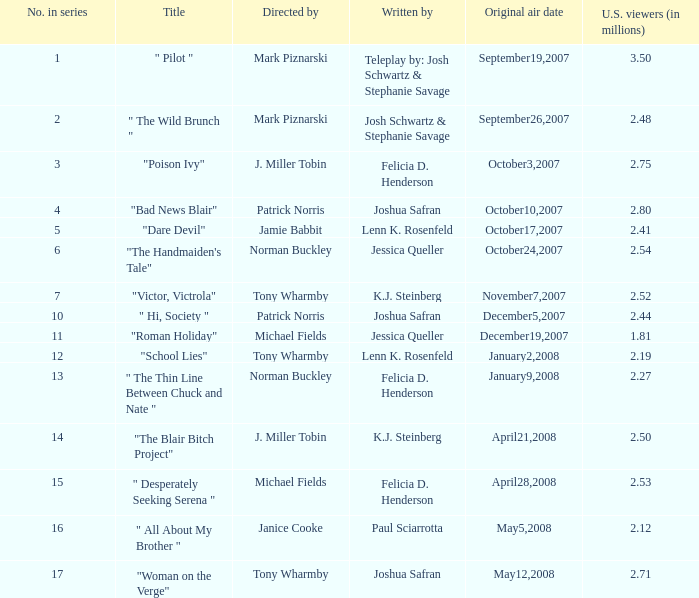What is the title when 2.50 is u.s. viewers (in millions)?  "The Blair Bitch Project". Parse the table in full. {'header': ['No. in series', 'Title', 'Directed by', 'Written by', 'Original air date', 'U.S. viewers (in millions)'], 'rows': [['1', '" Pilot "', 'Mark Piznarski', 'Teleplay by: Josh Schwartz & Stephanie Savage', 'September19,2007', '3.50'], ['2', '" The Wild Brunch "', 'Mark Piznarski', 'Josh Schwartz & Stephanie Savage', 'September26,2007', '2.48'], ['3', '"Poison Ivy"', 'J. Miller Tobin', 'Felicia D. Henderson', 'October3,2007', '2.75'], ['4', '"Bad News Blair"', 'Patrick Norris', 'Joshua Safran', 'October10,2007', '2.80'], ['5', '"Dare Devil"', 'Jamie Babbit', 'Lenn K. Rosenfeld', 'October17,2007', '2.41'], ['6', '"The Handmaiden\'s Tale"', 'Norman Buckley', 'Jessica Queller', 'October24,2007', '2.54'], ['7', '"Victor, Victrola"', 'Tony Wharmby', 'K.J. Steinberg', 'November7,2007', '2.52'], ['10', '" Hi, Society "', 'Patrick Norris', 'Joshua Safran', 'December5,2007', '2.44'], ['11', '"Roman Holiday"', 'Michael Fields', 'Jessica Queller', 'December19,2007', '1.81'], ['12', '"School Lies"', 'Tony Wharmby', 'Lenn K. Rosenfeld', 'January2,2008', '2.19'], ['13', '" The Thin Line Between Chuck and Nate "', 'Norman Buckley', 'Felicia D. Henderson', 'January9,2008', '2.27'], ['14', '"The Blair Bitch Project"', 'J. Miller Tobin', 'K.J. Steinberg', 'April21,2008', '2.50'], ['15', '" Desperately Seeking Serena "', 'Michael Fields', 'Felicia D. Henderson', 'April28,2008', '2.53'], ['16', '" All About My Brother "', 'Janice Cooke', 'Paul Sciarrotta', 'May5,2008', '2.12'], ['17', '"Woman on the Verge"', 'Tony Wharmby', 'Joshua Safran', 'May12,2008', '2.71']]} 